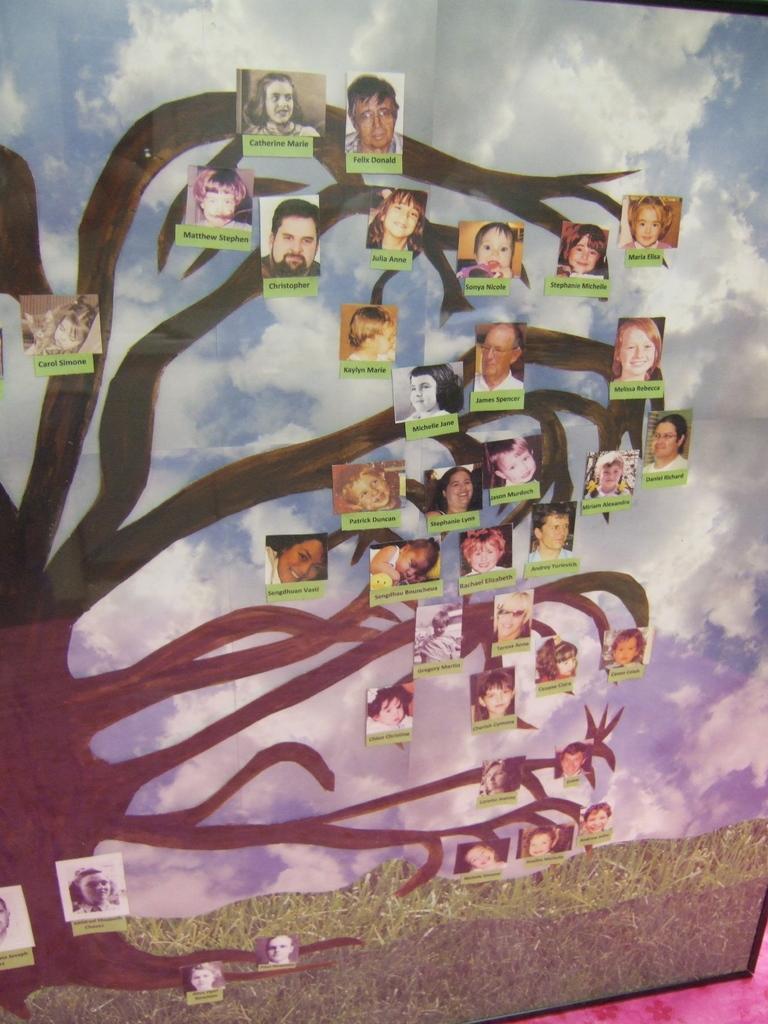Describe this image in one or two sentences. This is a picture of a frame , where there is a tree with photos and names of the people to the tree, sky, grass. 